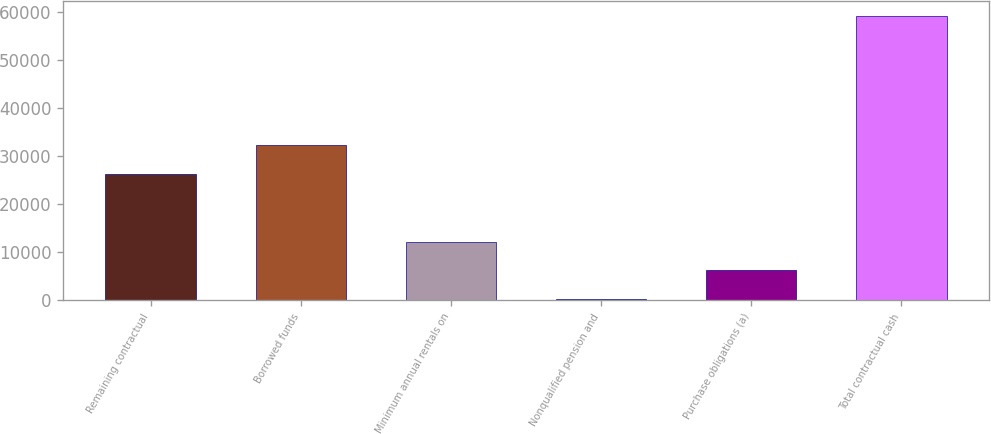Convert chart. <chart><loc_0><loc_0><loc_500><loc_500><bar_chart><fcel>Remaining contractual<fcel>Borrowed funds<fcel>Minimum annual rentals on<fcel>Nonqualified pension and<fcel>Purchase obligations (a)<fcel>Total contractual cash<nl><fcel>26402<fcel>32303.3<fcel>12116.6<fcel>314<fcel>6215.3<fcel>59327<nl></chart> 